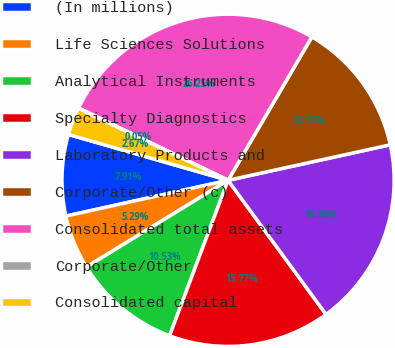Convert chart. <chart><loc_0><loc_0><loc_500><loc_500><pie_chart><fcel>(In millions)<fcel>Life Sciences Solutions<fcel>Analytical Instruments<fcel>Specialty Diagnostics<fcel>Laboratory Products and<fcel>Corporate/Other (c)<fcel>Consolidated total assets<fcel>Corporate/Other<fcel>Consolidated capital<nl><fcel>7.91%<fcel>5.29%<fcel>10.53%<fcel>15.77%<fcel>18.39%<fcel>13.15%<fcel>26.25%<fcel>0.05%<fcel>2.67%<nl></chart> 